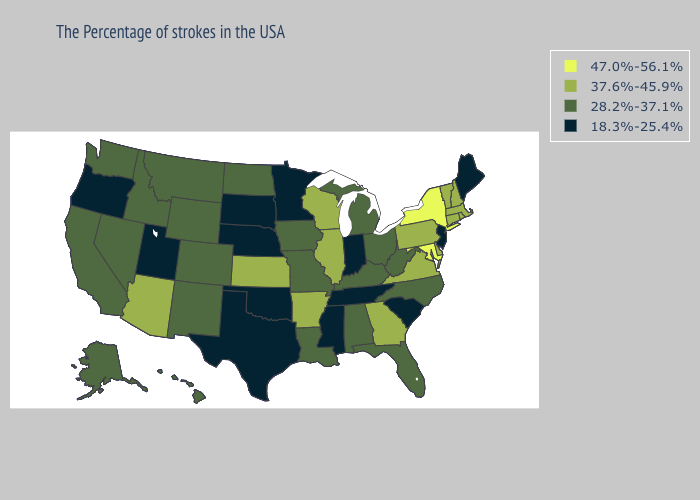What is the value of New Jersey?
Short answer required. 18.3%-25.4%. Does Oregon have the highest value in the West?
Write a very short answer. No. Among the states that border North Carolina , which have the highest value?
Give a very brief answer. Virginia, Georgia. Does Maryland have the highest value in the USA?
Quick response, please. Yes. What is the value of Missouri?
Give a very brief answer. 28.2%-37.1%. What is the value of Virginia?
Concise answer only. 37.6%-45.9%. How many symbols are there in the legend?
Answer briefly. 4. Name the states that have a value in the range 47.0%-56.1%?
Give a very brief answer. New York, Maryland. What is the value of North Carolina?
Write a very short answer. 28.2%-37.1%. Among the states that border West Virginia , which have the highest value?
Short answer required. Maryland. Which states have the lowest value in the West?
Answer briefly. Utah, Oregon. What is the lowest value in the USA?
Concise answer only. 18.3%-25.4%. Does North Carolina have the lowest value in the USA?
Quick response, please. No. Name the states that have a value in the range 37.6%-45.9%?
Give a very brief answer. Massachusetts, Rhode Island, New Hampshire, Vermont, Connecticut, Delaware, Pennsylvania, Virginia, Georgia, Wisconsin, Illinois, Arkansas, Kansas, Arizona. What is the value of Kentucky?
Write a very short answer. 28.2%-37.1%. 